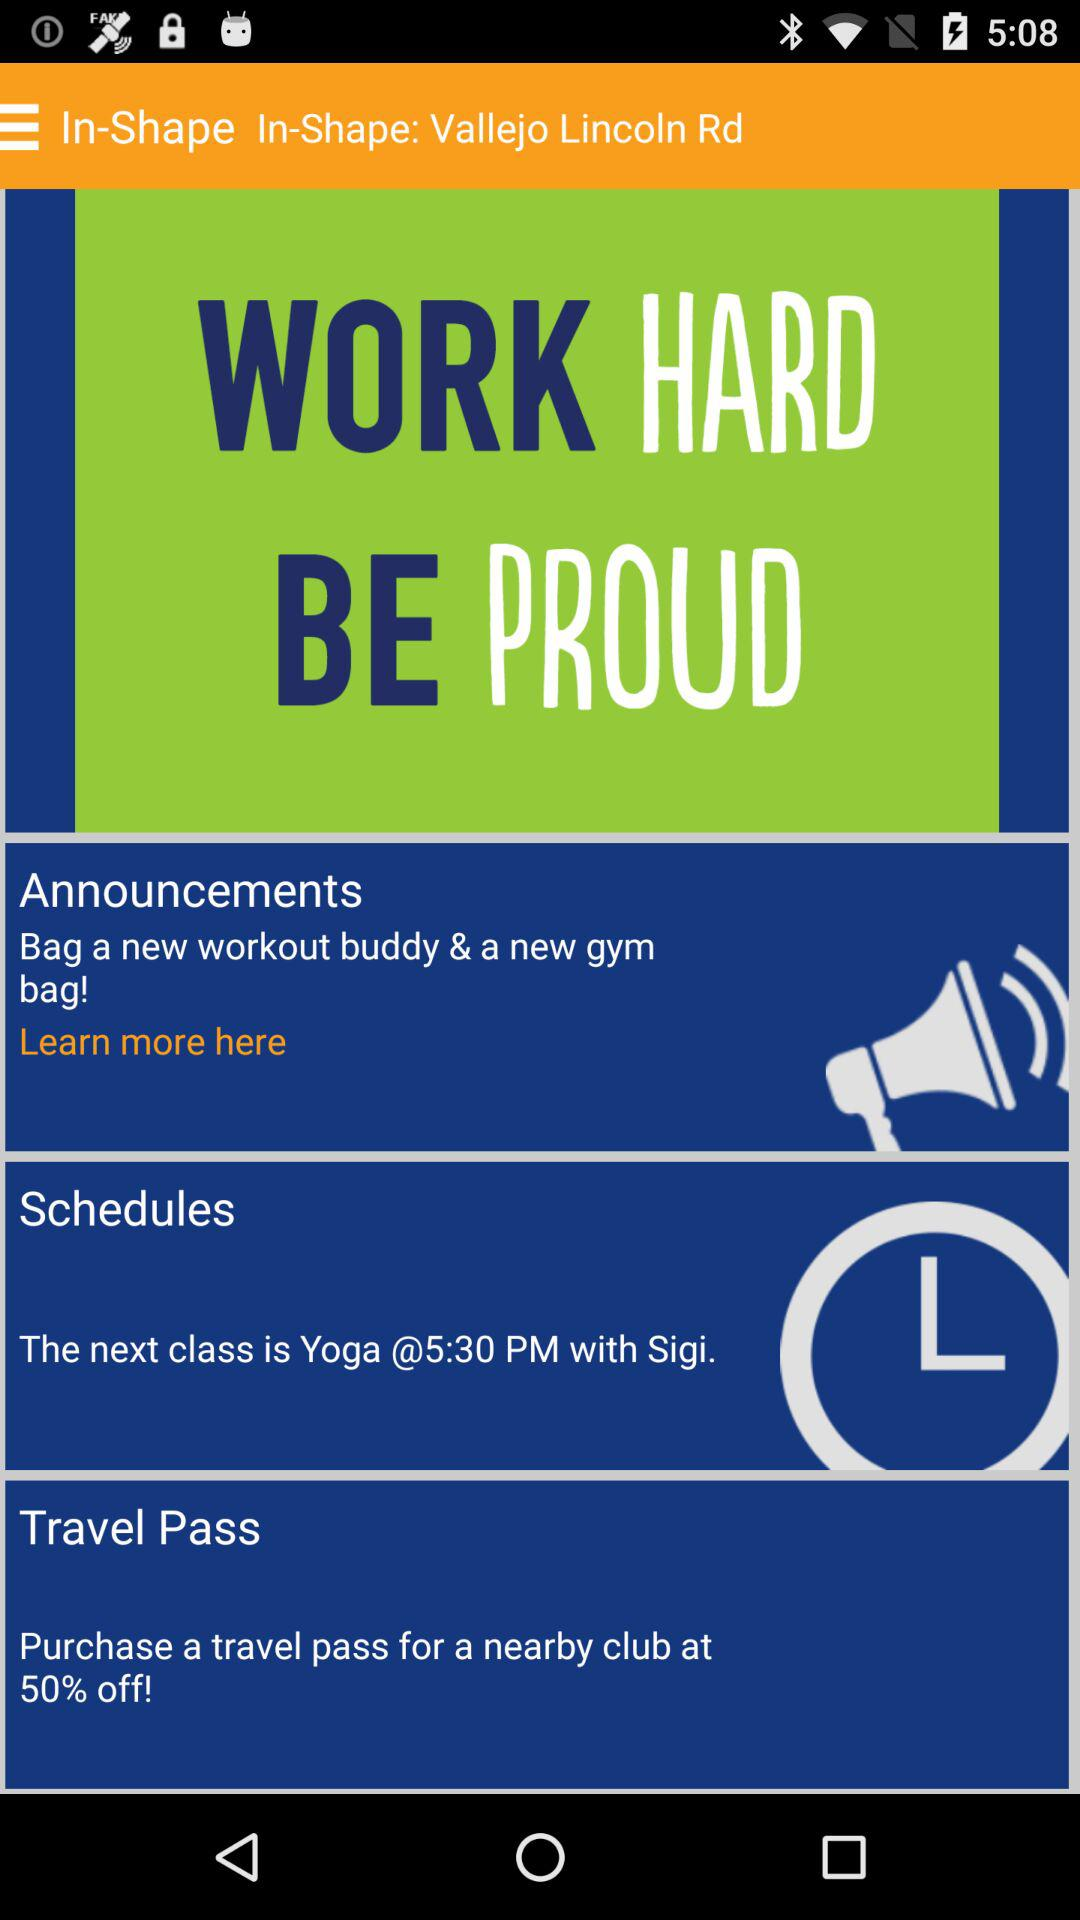At what time is the next yoga class scheduled? The next yoga class is scheduled for 5:30 PM. 